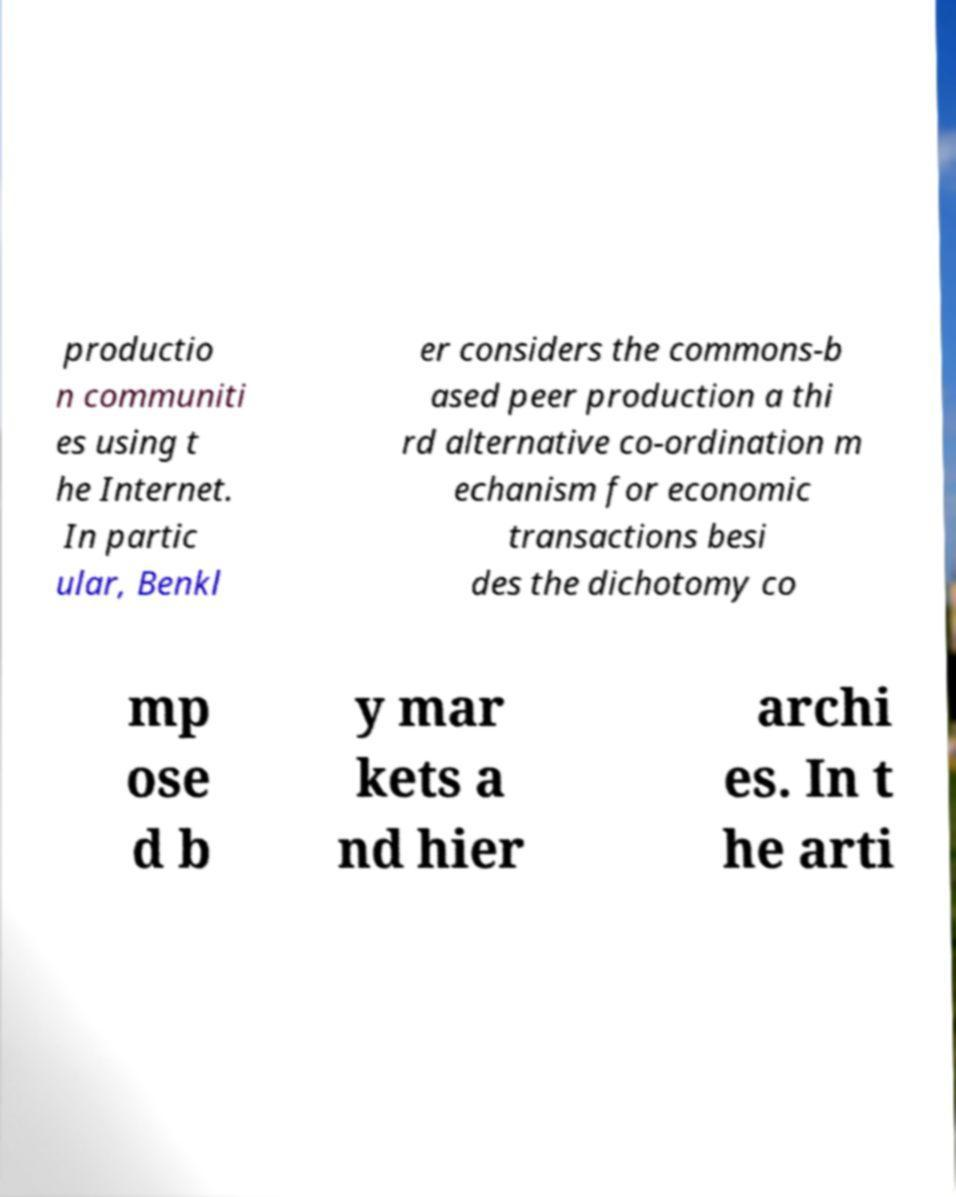I need the written content from this picture converted into text. Can you do that? productio n communiti es using t he Internet. In partic ular, Benkl er considers the commons-b ased peer production a thi rd alternative co-ordination m echanism for economic transactions besi des the dichotomy co mp ose d b y mar kets a nd hier archi es. In t he arti 